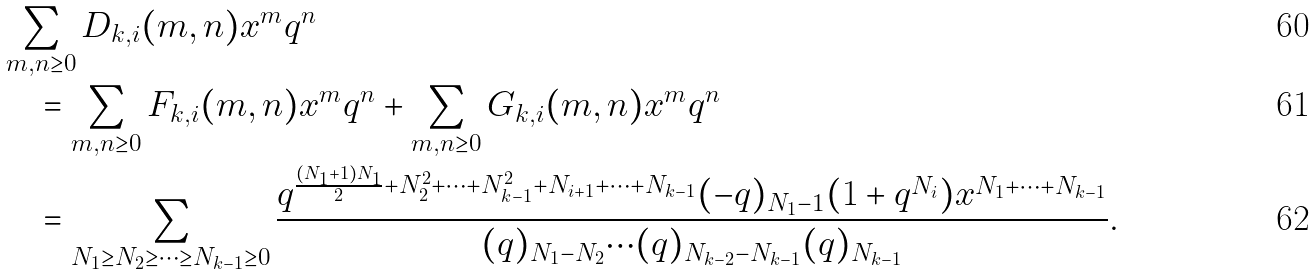<formula> <loc_0><loc_0><loc_500><loc_500>& \sum _ { m , n \geq 0 } D _ { k , i } ( m , n ) x ^ { m } q ^ { n } \\ & \quad = \sum _ { m , n \geq 0 } F _ { k , i } ( m , n ) x ^ { m } q ^ { n } + \sum _ { m , n \geq 0 } G _ { k , i } ( m , n ) x ^ { m } q ^ { n } \\ & \quad = \sum _ { N _ { 1 } \geq N _ { 2 } \geq \cdots \geq N _ { k - 1 } \geq 0 } \frac { q ^ { \frac { ( N _ { 1 } + 1 ) N _ { 1 } } { 2 } + N _ { 2 } ^ { 2 } + \cdots + N _ { k - 1 } ^ { 2 } + N _ { i + 1 } + \cdots + N _ { k - 1 } } ( - q ) _ { N _ { 1 } - 1 } ( 1 + q ^ { N _ { i } } ) x ^ { N _ { 1 } + \cdots + N _ { k - 1 } } } { ( q ) _ { N _ { 1 } - N _ { 2 } } \cdots ( q ) _ { N _ { k - 2 } - N _ { k - 1 } } ( q ) _ { N _ { k - 1 } } } .</formula> 